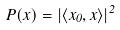Convert formula to latex. <formula><loc_0><loc_0><loc_500><loc_500>P ( x ) = | \langle x _ { 0 } , x \rangle | ^ { 2 }</formula> 